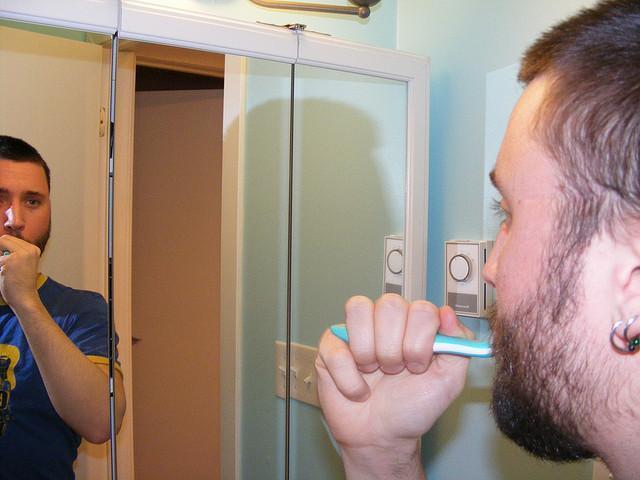How many earrings does he have?
Give a very brief answer. 2. How many people are in the photo?
Give a very brief answer. 2. How many bottles on the cutting board are uncorked?
Give a very brief answer. 0. 